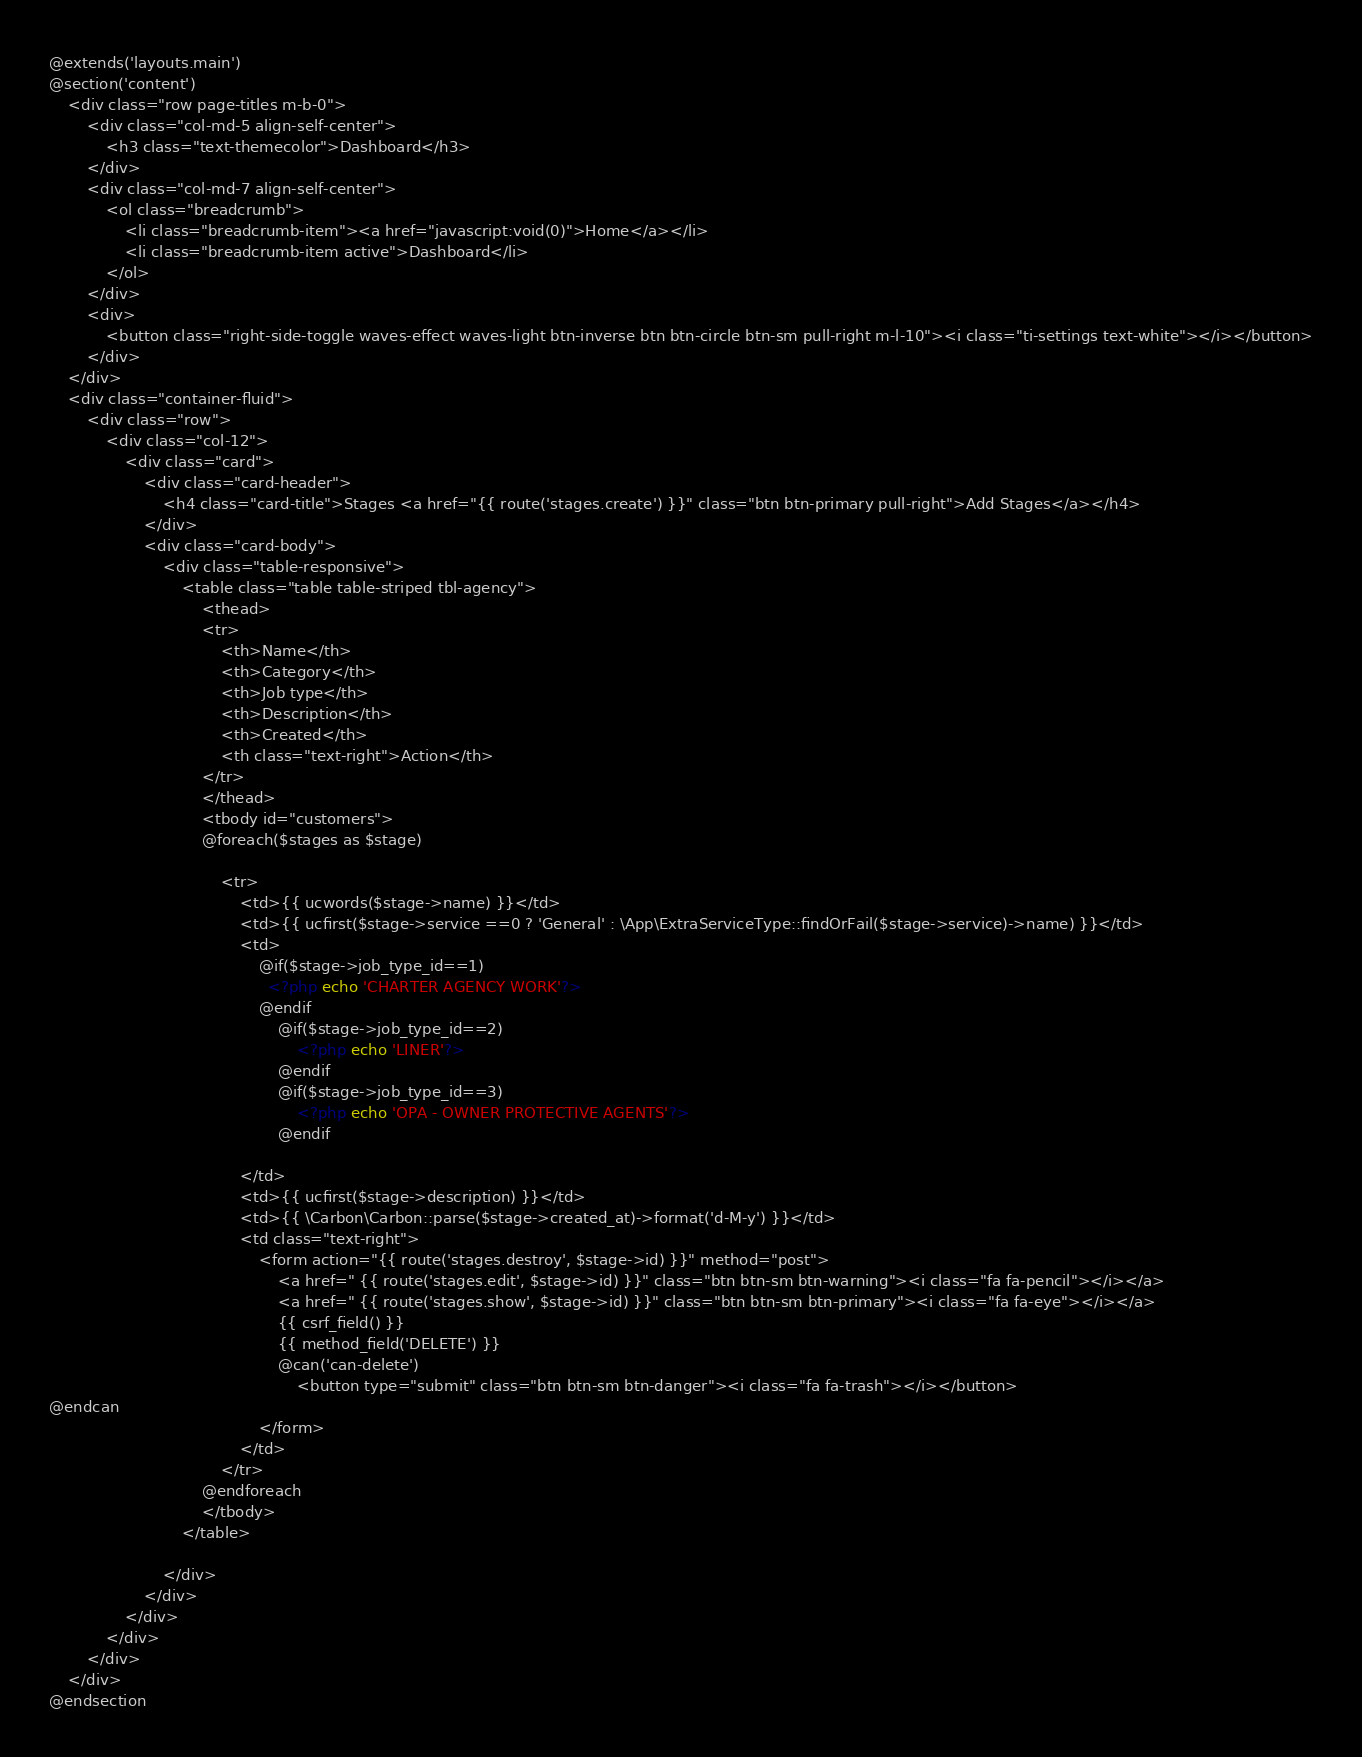Convert code to text. <code><loc_0><loc_0><loc_500><loc_500><_PHP_>@extends('layouts.main')
@section('content')
    <div class="row page-titles m-b-0">
        <div class="col-md-5 align-self-center">
            <h3 class="text-themecolor">Dashboard</h3>
        </div>
        <div class="col-md-7 align-self-center">
            <ol class="breadcrumb">
                <li class="breadcrumb-item"><a href="javascript:void(0)">Home</a></li>
                <li class="breadcrumb-item active">Dashboard</li>
            </ol>
        </div>
        <div>
            <button class="right-side-toggle waves-effect waves-light btn-inverse btn btn-circle btn-sm pull-right m-l-10"><i class="ti-settings text-white"></i></button>
        </div>
    </div>
    <div class="container-fluid">
        <div class="row">
            <div class="col-12">
                <div class="card">
                    <div class="card-header">
                        <h4 class="card-title">Stages <a href="{{ route('stages.create') }}" class="btn btn-primary pull-right">Add Stages</a></h4>
                    </div>
                    <div class="card-body">
                        <div class="table-responsive">
                            <table class="table table-striped tbl-agency">
                                <thead>
                                <tr>
                                    <th>Name</th>
                                    <th>Category</th>
                                    <th>Job type</th>
                                    <th>Description</th>
                                    <th>Created</th>
                                    <th class="text-right">Action</th>
                                </tr>
                                </thead>
                                <tbody id="customers">
                                @foreach($stages as $stage)

                                    <tr>
                                        <td>{{ ucwords($stage->name) }}</td>
                                        <td>{{ ucfirst($stage->service ==0 ? 'General' : \App\ExtraServiceType::findOrFail($stage->service)->name) }}</td>
                                        <td>
                                            @if($stage->job_type_id==1)
                                              <?php echo 'CHARTER AGENCY WORK'?>
                                            @endif
                                                @if($stage->job_type_id==2)
                                                    <?php echo 'LINER'?>
                                                @endif
                                                @if($stage->job_type_id==3)
                                                    <?php echo 'OPA - OWNER PROTECTIVE AGENTS'?>
                                                @endif

                                        </td>
                                        <td>{{ ucfirst($stage->description) }}</td>
                                        <td>{{ \Carbon\Carbon::parse($stage->created_at)->format('d-M-y') }}</td>
                                        <td class="text-right">
                                            <form action="{{ route('stages.destroy', $stage->id) }}" method="post">
                                                <a href=" {{ route('stages.edit', $stage->id) }}" class="btn btn-sm btn-warning"><i class="fa fa-pencil"></i></a>
                                                <a href=" {{ route('stages.show', $stage->id) }}" class="btn btn-sm btn-primary"><i class="fa fa-eye"></i></a>
                                                {{ csrf_field() }}
                                                {{ method_field('DELETE') }}
                                                @can('can-delete')
                                                    <button type="submit" class="btn btn-sm btn-danger"><i class="fa fa-trash"></i></button>
@endcan
                                            </form>
                                        </td>
                                    </tr>
                                @endforeach
                                </tbody>
                            </table>

                        </div>
                    </div>
                </div>
            </div>
        </div>
    </div>
@endsection
</code> 